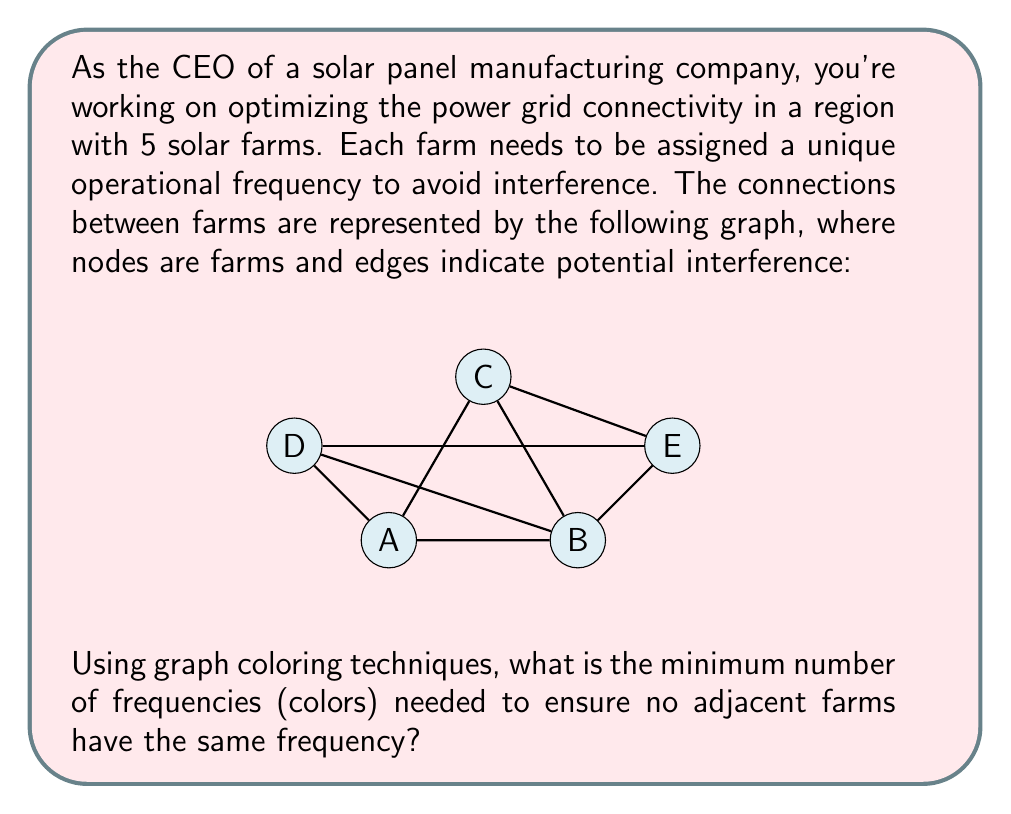Solve this math problem. To solve this problem, we'll use graph coloring techniques. The goal is to assign a color (frequency) to each node (farm) such that no adjacent nodes have the same color. The minimum number of colors required is called the chromatic number of the graph.

Step 1: Analyze the graph structure
- The graph has 5 nodes (A, B, C, D, E)
- It forms a complex structure with multiple connections

Step 2: Apply the greedy coloring algorithm
1) Start with node A, assign it color 1
2) Move to B, it's connected to A, so assign it color 2
3) For C:
   - Connected to A and B, so can't use colors 1 or 2
   - Assign it color 3
4) For D:
   - Connected to A and B, but not C
   - Can use color 3
5) For E:
   - Connected to B, C, and D
   - Need a new color, assign it color 4

Step 3: Verify the coloring
- A: Color 1
- B: Color 2
- C: Color 3
- D: Color 3
- E: Color 4

Step 4: Optimize
- This coloring uses 4 colors
- No obvious way to reduce this further

Step 5: Prove optimality
- The graph contains a clique (fully connected subgraph) of size 3 (A-B-C)
- Any clique of size k requires at least k colors
- Therefore, the chromatic number is at least 3
- We found a valid 4-coloring, and can't use 3 colors due to node E

Therefore, the minimum number of colors (frequencies) needed is 4.
Answer: 4 